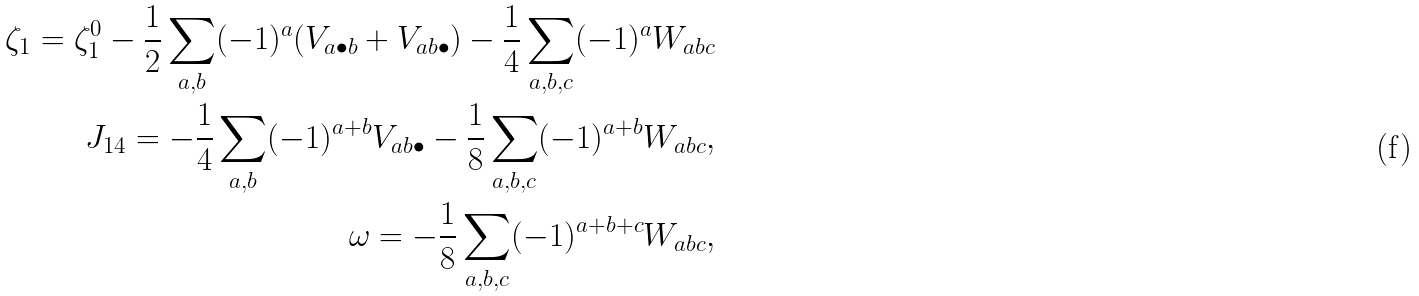<formula> <loc_0><loc_0><loc_500><loc_500>\zeta _ { 1 } = \zeta ^ { 0 } _ { 1 } - \frac { 1 } { 2 } \sum _ { a , b } ( - 1 ) ^ { a } ( V _ { a \bullet b } + V _ { a b \bullet } ) - \frac { 1 } { 4 } \sum _ { a , b , c } ( - 1 ) ^ { a } W _ { a b c } \\ J _ { 1 4 } = - \frac { 1 } { 4 } \sum _ { a , b } ( - 1 ) ^ { a + b } V _ { a b \bullet } - \frac { 1 } { 8 } \sum _ { a , b , c } ( - 1 ) ^ { a + b } W _ { a b c } , \\ \omega = - \frac { 1 } { 8 } \sum _ { a , b , c } ( - 1 ) ^ { a + b + c } W _ { a b c } ,</formula> 